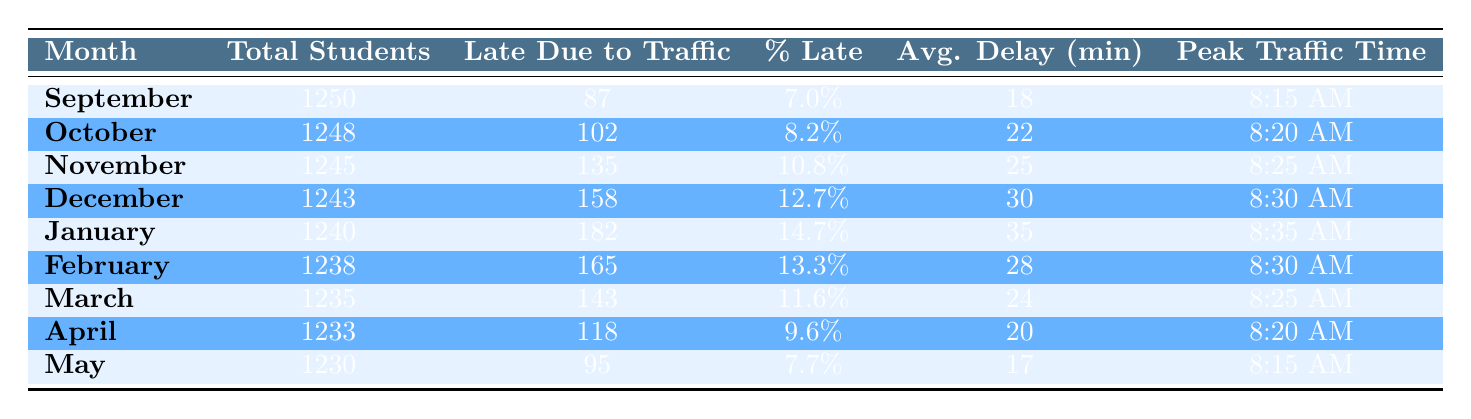What was the highest percentage of students late due to traffic in any month? The highest percentage shown in the table is found in January at 14.7%. I locate this by examining the "% Late" column and identifying the maximum value.
Answer: 14.7% In which month were the most students late due to traffic? The month with the highest number of students late due to traffic is January with 182 students. I review the "Late Due to Traffic" column to find the maximum value.
Answer: January What is the average delay time for students who were late due to traffic in December? The table shows that the average delay time for December is 30 minutes, which I find directly in the "Avg. Delay (min)" column for that month.
Answer: 30 What is the total number of students late due to traffic from September to May combined? To find the total, I sum the late student counts from each month: 87 + 102 + 135 + 158 + 182 + 165 + 143 + 118 + 95 = 1085. I perform this calculation by adding each monthly figure.
Answer: 1085 Is the percentage of students late higher in February than in March? By comparing the values in the "% Late" column, February shows 13.3% and March shows 11.6%. Since 13.3% is greater than 11.6%, the answer is true.
Answer: Yes If we look at the peak traffic times, which month had the latest peak time? The latest peak traffic time is in January at 8:35 AM. I identify this by scanning the "Peak Traffic Time" column for the latest time.
Answer: January What is the overall percentage of students late due to traffic from September to May? I calculate the overall percentage by dividing the total number of late students by the total number of students: 1085 late students out of 11248 total students (sum of all months). Hence, the percentage is (1085/11248) * 100, which equals approximately 9.66%.
Answer: 9.66% Was there a month where less than 10% of students were late due to traffic? From the table, both September (7.0%) and May (7.7%) show percentages below 10%. I check the "% Late" column for these specific values.
Answer: Yes What is the trend in the average delay time from September to January? Looking at the "Avg. Delay (min)" values, I see they consistently increased from 18 minutes in September to 35 minutes in January. I confirm this by comparing the values in this column month by month.
Answer: Increase 